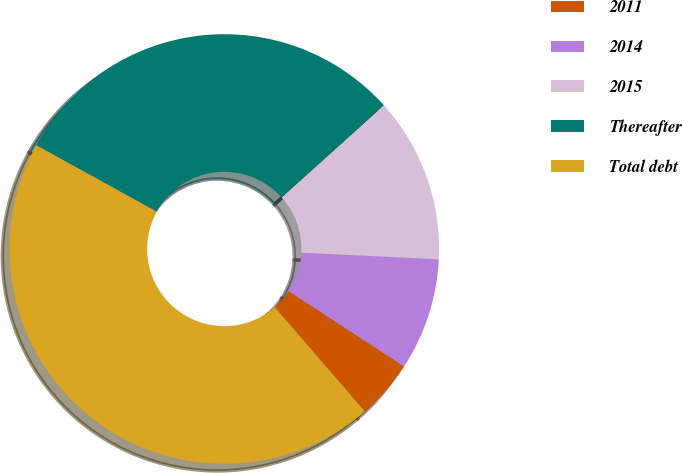<chart> <loc_0><loc_0><loc_500><loc_500><pie_chart><fcel>2011<fcel>2014<fcel>2015<fcel>Thereafter<fcel>Total debt<nl><fcel>4.45%<fcel>8.44%<fcel>12.43%<fcel>30.31%<fcel>44.36%<nl></chart> 